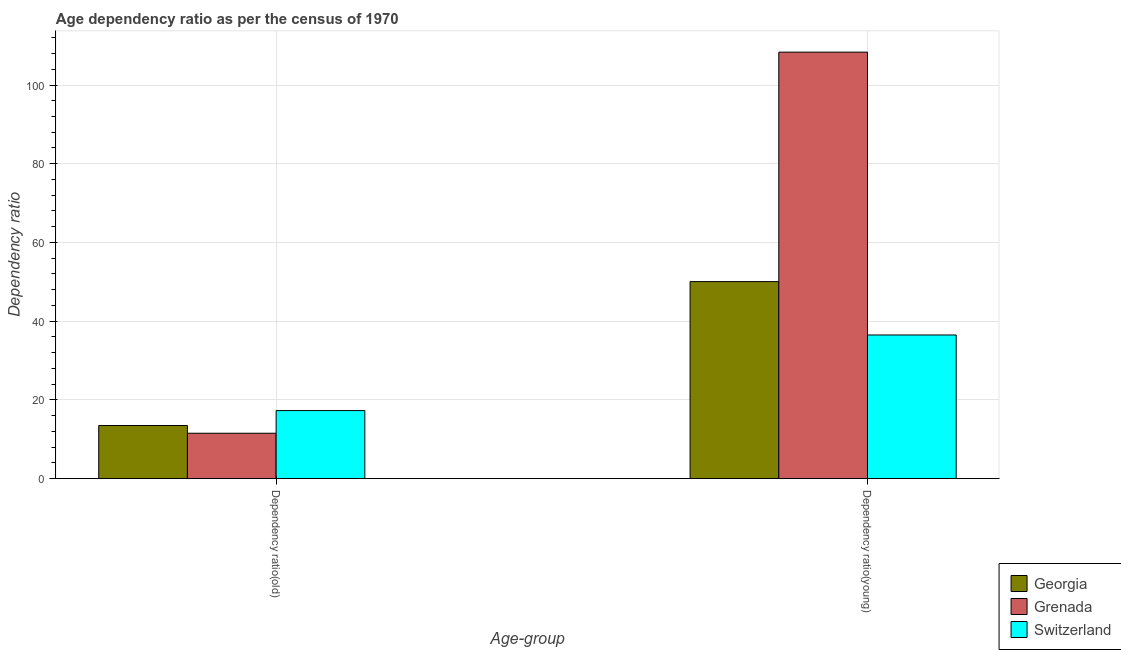How many groups of bars are there?
Ensure brevity in your answer.  2. Are the number of bars per tick equal to the number of legend labels?
Your response must be concise. Yes. How many bars are there on the 2nd tick from the left?
Give a very brief answer. 3. How many bars are there on the 2nd tick from the right?
Offer a terse response. 3. What is the label of the 2nd group of bars from the left?
Your answer should be compact. Dependency ratio(young). What is the age dependency ratio(old) in Grenada?
Your answer should be compact. 11.53. Across all countries, what is the maximum age dependency ratio(old)?
Offer a terse response. 17.28. Across all countries, what is the minimum age dependency ratio(young)?
Your answer should be compact. 36.49. In which country was the age dependency ratio(young) maximum?
Give a very brief answer. Grenada. In which country was the age dependency ratio(old) minimum?
Provide a short and direct response. Grenada. What is the total age dependency ratio(young) in the graph?
Your answer should be very brief. 194.89. What is the difference between the age dependency ratio(young) in Georgia and that in Grenada?
Your response must be concise. -58.3. What is the difference between the age dependency ratio(young) in Georgia and the age dependency ratio(old) in Switzerland?
Your answer should be very brief. 32.77. What is the average age dependency ratio(old) per country?
Keep it short and to the point. 14.1. What is the difference between the age dependency ratio(old) and age dependency ratio(young) in Switzerland?
Provide a short and direct response. -19.21. In how many countries, is the age dependency ratio(old) greater than 60 ?
Your response must be concise. 0. What is the ratio of the age dependency ratio(young) in Switzerland to that in Georgia?
Provide a short and direct response. 0.73. What does the 1st bar from the left in Dependency ratio(old) represents?
Provide a succinct answer. Georgia. What does the 2nd bar from the right in Dependency ratio(old) represents?
Your answer should be very brief. Grenada. Does the graph contain grids?
Ensure brevity in your answer.  Yes. How many legend labels are there?
Offer a terse response. 3. What is the title of the graph?
Provide a short and direct response. Age dependency ratio as per the census of 1970. Does "Mauritania" appear as one of the legend labels in the graph?
Give a very brief answer. No. What is the label or title of the X-axis?
Your response must be concise. Age-group. What is the label or title of the Y-axis?
Offer a terse response. Dependency ratio. What is the Dependency ratio in Georgia in Dependency ratio(old)?
Your answer should be compact. 13.5. What is the Dependency ratio of Grenada in Dependency ratio(old)?
Give a very brief answer. 11.53. What is the Dependency ratio in Switzerland in Dependency ratio(old)?
Give a very brief answer. 17.28. What is the Dependency ratio in Georgia in Dependency ratio(young)?
Offer a terse response. 50.05. What is the Dependency ratio of Grenada in Dependency ratio(young)?
Keep it short and to the point. 108.35. What is the Dependency ratio in Switzerland in Dependency ratio(young)?
Ensure brevity in your answer.  36.49. Across all Age-group, what is the maximum Dependency ratio in Georgia?
Your answer should be compact. 50.05. Across all Age-group, what is the maximum Dependency ratio of Grenada?
Keep it short and to the point. 108.35. Across all Age-group, what is the maximum Dependency ratio in Switzerland?
Make the answer very short. 36.49. Across all Age-group, what is the minimum Dependency ratio in Georgia?
Give a very brief answer. 13.5. Across all Age-group, what is the minimum Dependency ratio of Grenada?
Make the answer very short. 11.53. Across all Age-group, what is the minimum Dependency ratio in Switzerland?
Give a very brief answer. 17.28. What is the total Dependency ratio of Georgia in the graph?
Give a very brief answer. 63.55. What is the total Dependency ratio in Grenada in the graph?
Keep it short and to the point. 119.88. What is the total Dependency ratio in Switzerland in the graph?
Offer a terse response. 53.77. What is the difference between the Dependency ratio in Georgia in Dependency ratio(old) and that in Dependency ratio(young)?
Provide a succinct answer. -36.55. What is the difference between the Dependency ratio in Grenada in Dependency ratio(old) and that in Dependency ratio(young)?
Provide a short and direct response. -96.82. What is the difference between the Dependency ratio in Switzerland in Dependency ratio(old) and that in Dependency ratio(young)?
Provide a succinct answer. -19.21. What is the difference between the Dependency ratio in Georgia in Dependency ratio(old) and the Dependency ratio in Grenada in Dependency ratio(young)?
Make the answer very short. -94.85. What is the difference between the Dependency ratio of Georgia in Dependency ratio(old) and the Dependency ratio of Switzerland in Dependency ratio(young)?
Your answer should be very brief. -23. What is the difference between the Dependency ratio of Grenada in Dependency ratio(old) and the Dependency ratio of Switzerland in Dependency ratio(young)?
Your answer should be very brief. -24.96. What is the average Dependency ratio of Georgia per Age-group?
Provide a short and direct response. 31.77. What is the average Dependency ratio in Grenada per Age-group?
Ensure brevity in your answer.  59.94. What is the average Dependency ratio of Switzerland per Age-group?
Offer a terse response. 26.89. What is the difference between the Dependency ratio in Georgia and Dependency ratio in Grenada in Dependency ratio(old)?
Offer a very short reply. 1.97. What is the difference between the Dependency ratio of Georgia and Dependency ratio of Switzerland in Dependency ratio(old)?
Give a very brief answer. -3.79. What is the difference between the Dependency ratio of Grenada and Dependency ratio of Switzerland in Dependency ratio(old)?
Your answer should be compact. -5.75. What is the difference between the Dependency ratio of Georgia and Dependency ratio of Grenada in Dependency ratio(young)?
Your response must be concise. -58.3. What is the difference between the Dependency ratio of Georgia and Dependency ratio of Switzerland in Dependency ratio(young)?
Make the answer very short. 13.56. What is the difference between the Dependency ratio of Grenada and Dependency ratio of Switzerland in Dependency ratio(young)?
Provide a short and direct response. 71.86. What is the ratio of the Dependency ratio of Georgia in Dependency ratio(old) to that in Dependency ratio(young)?
Give a very brief answer. 0.27. What is the ratio of the Dependency ratio of Grenada in Dependency ratio(old) to that in Dependency ratio(young)?
Offer a very short reply. 0.11. What is the ratio of the Dependency ratio of Switzerland in Dependency ratio(old) to that in Dependency ratio(young)?
Make the answer very short. 0.47. What is the difference between the highest and the second highest Dependency ratio in Georgia?
Your answer should be compact. 36.55. What is the difference between the highest and the second highest Dependency ratio in Grenada?
Offer a very short reply. 96.82. What is the difference between the highest and the second highest Dependency ratio in Switzerland?
Offer a terse response. 19.21. What is the difference between the highest and the lowest Dependency ratio of Georgia?
Give a very brief answer. 36.55. What is the difference between the highest and the lowest Dependency ratio of Grenada?
Ensure brevity in your answer.  96.82. What is the difference between the highest and the lowest Dependency ratio of Switzerland?
Your answer should be very brief. 19.21. 